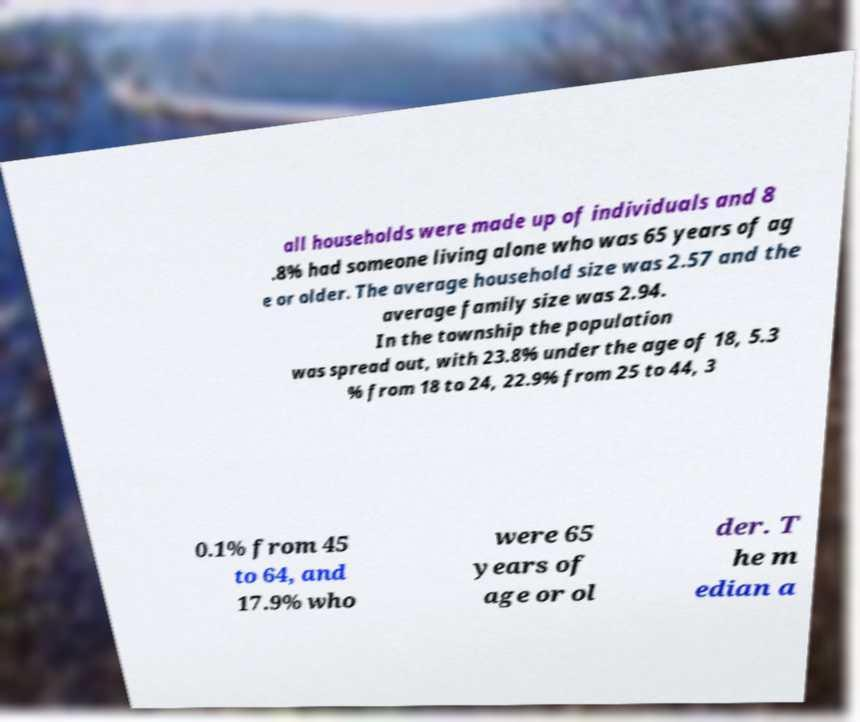Can you read and provide the text displayed in the image?This photo seems to have some interesting text. Can you extract and type it out for me? all households were made up of individuals and 8 .8% had someone living alone who was 65 years of ag e or older. The average household size was 2.57 and the average family size was 2.94. In the township the population was spread out, with 23.8% under the age of 18, 5.3 % from 18 to 24, 22.9% from 25 to 44, 3 0.1% from 45 to 64, and 17.9% who were 65 years of age or ol der. T he m edian a 